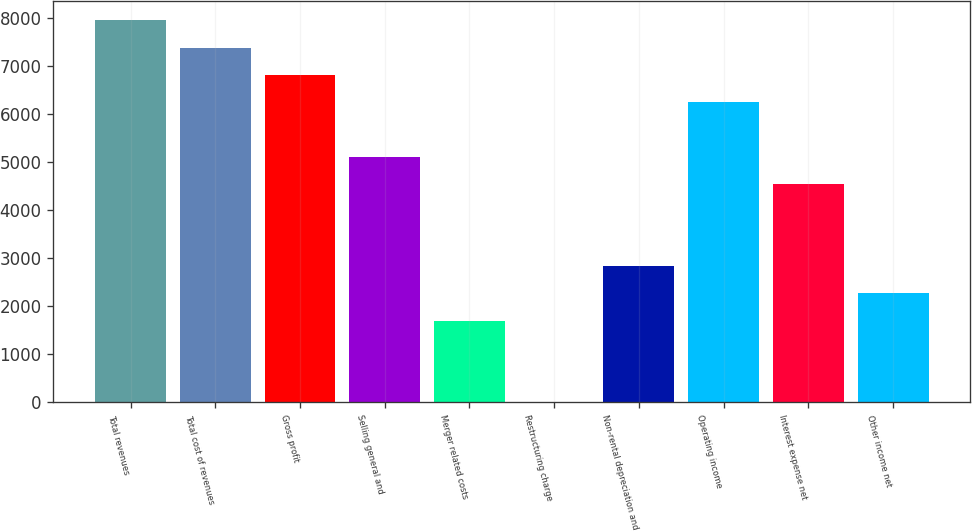<chart> <loc_0><loc_0><loc_500><loc_500><bar_chart><fcel>Total revenues<fcel>Total cost of revenues<fcel>Gross profit<fcel>Selling general and<fcel>Merger related costs<fcel>Restructuring charge<fcel>Non-rental depreciation and<fcel>Operating income<fcel>Interest expense net<fcel>Other income net<nl><fcel>7958.6<fcel>7390.2<fcel>6821.8<fcel>5116.6<fcel>1706.2<fcel>1<fcel>2843<fcel>6253.4<fcel>4548.2<fcel>2274.6<nl></chart> 